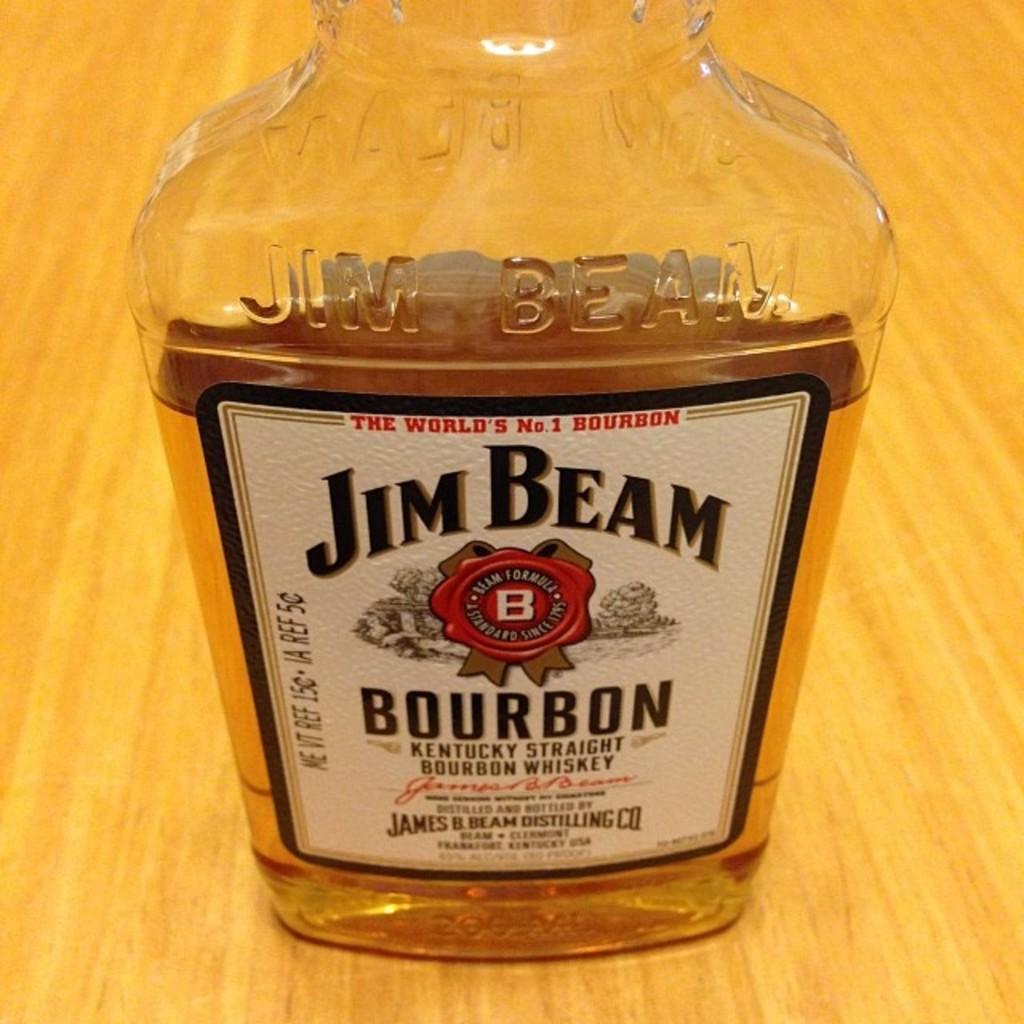What type of liquor is in this bottle?
Provide a short and direct response. Bourbon. What is the brand name of this liquor?
Provide a short and direct response. Jim beam. 